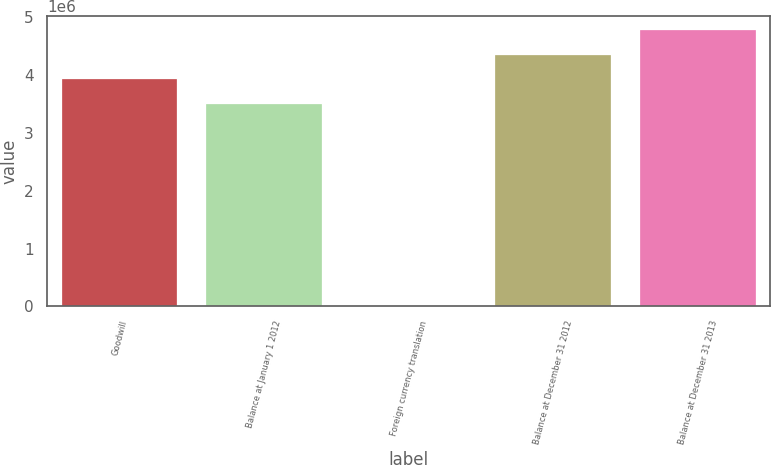Convert chart. <chart><loc_0><loc_0><loc_500><loc_500><bar_chart><fcel>Goodwill<fcel>Balance at January 1 2012<fcel>Foreign currency translation<fcel>Balance at December 31 2012<fcel>Balance at December 31 2013<nl><fcel>3.93001e+06<fcel>3.50698e+06<fcel>12575<fcel>4.35304e+06<fcel>4.77608e+06<nl></chart> 